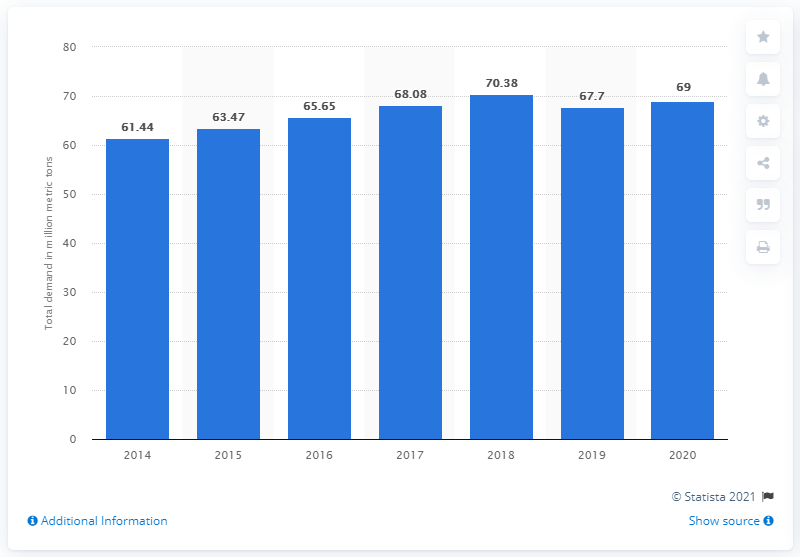Point out several critical features in this image. The expected annual demand for sulfur fertilizer is projected to reach 69 by 2020. 